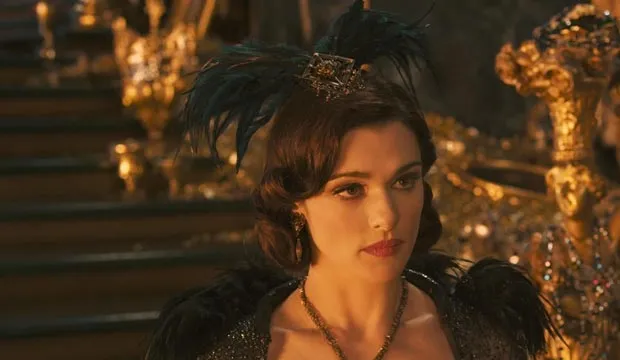What do you think the woman in the image is thinking about? Judging by her serious expression and the grandeur of her surroundings, it's likely that the woman is contemplating a significant decision. Perhaps she is considering a strategic move, reflecting on past events, or strategizing for an impending conflict. The opulence of her attire and backdrop suggests that her thoughts are of great importance, possibly influencing the future of a kingdom or power struggle. 